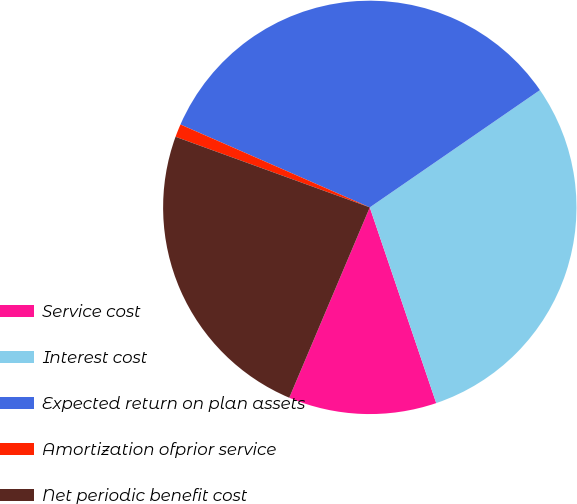Convert chart to OTSL. <chart><loc_0><loc_0><loc_500><loc_500><pie_chart><fcel>Service cost<fcel>Interest cost<fcel>Expected return on plan assets<fcel>Amortization ofprior service<fcel>Net periodic benefit cost<nl><fcel>11.58%<fcel>29.4%<fcel>33.83%<fcel>1.02%<fcel>24.18%<nl></chart> 